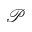Convert formula to latex. <formula><loc_0><loc_0><loc_500><loc_500>\mathcal { P }</formula> 